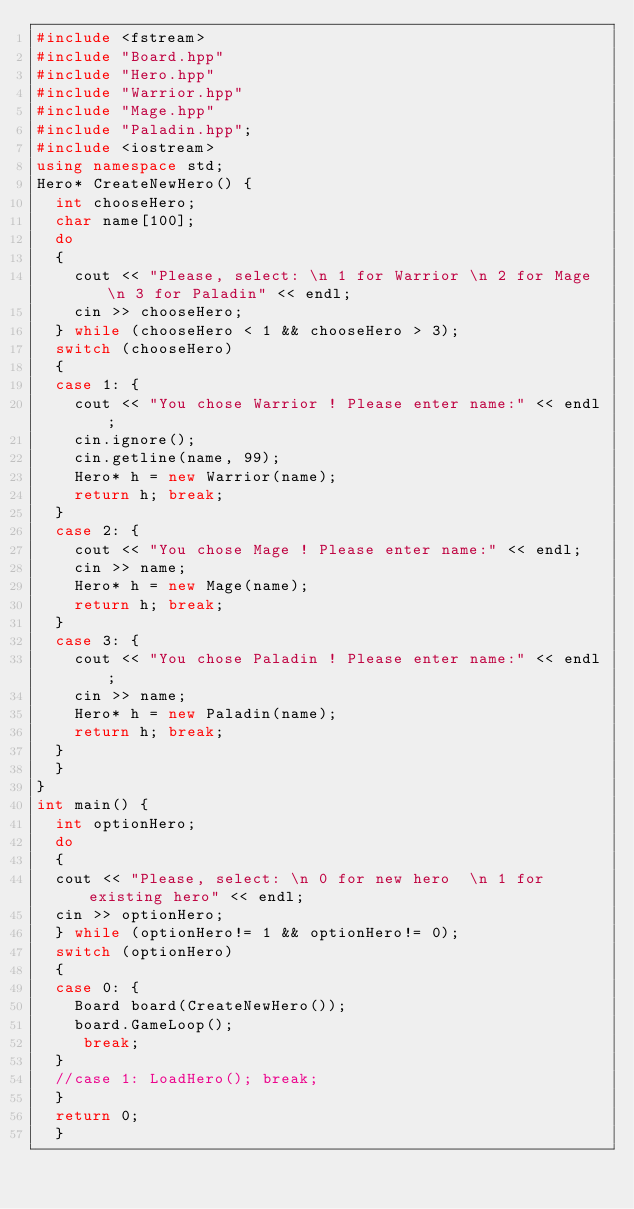<code> <loc_0><loc_0><loc_500><loc_500><_C++_>#include <fstream> 
#include "Board.hpp"
#include "Hero.hpp"
#include "Warrior.hpp"
#include "Mage.hpp"
#include "Paladin.hpp";
#include <iostream>
using namespace std;
Hero* CreateNewHero() {
	int chooseHero;
	char name[100];
	do
	{
		cout << "Please, select: \n 1 for Warrior \n 2 for Mage \n 3 for Paladin" << endl;
		cin >> chooseHero;
	} while (chooseHero < 1 && chooseHero > 3);
	switch (chooseHero)
	{
	case 1: {
		cout << "You chose Warrior ! Please enter name:" << endl;
		cin.ignore();
		cin.getline(name, 99);
		Hero* h = new Warrior(name);
		return h; break;
	}
	case 2: {
		cout << "You chose Mage ! Please enter name:" << endl;
		cin >> name;
		Hero* h = new Mage(name);
		return h; break;
	}
	case 3: {
		cout << "You chose Paladin ! Please enter name:" << endl;
		cin >> name;
		Hero* h = new Paladin(name);
		return h; break;
	}
	}
}
int main() {
	int optionHero;
	do
	{
	cout << "Please, select: \n 0 for new hero  \n 1 for existing hero" << endl;
	cin >> optionHero;
	} while (optionHero!= 1 && optionHero!= 0);
	switch (optionHero)
	{
	case 0: {
		Board board(CreateNewHero());
		board.GameLoop();
		 break;
	}
	//case 1: LoadHero(); break;
	}
	return 0;
	}
</code> 